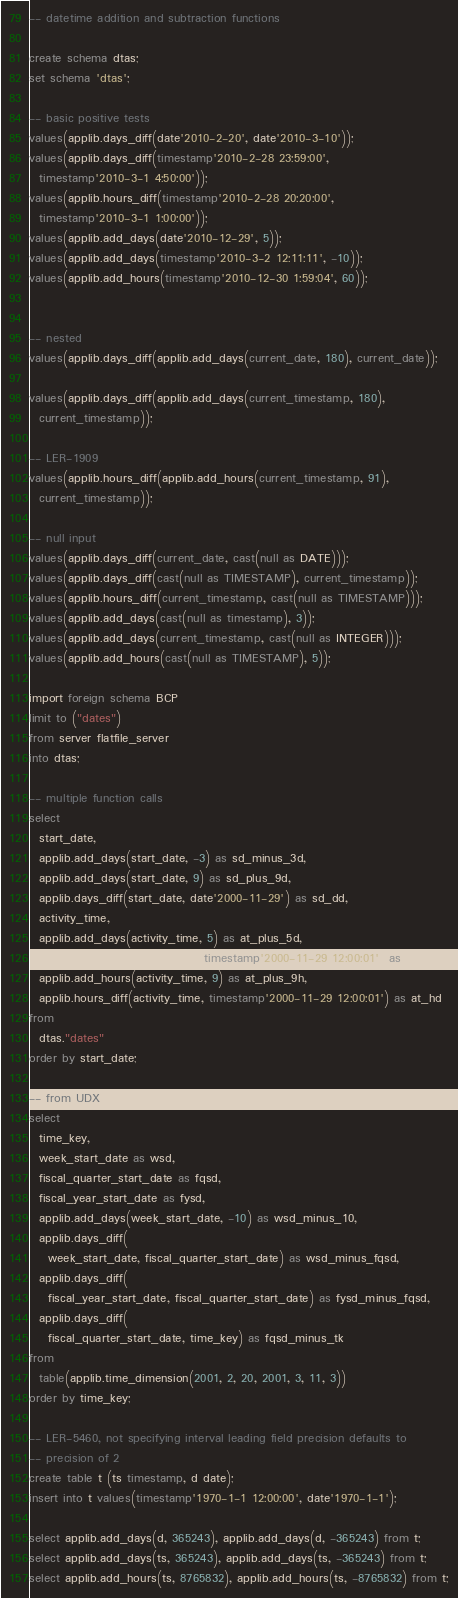Convert code to text. <code><loc_0><loc_0><loc_500><loc_500><_SQL_>-- datetime addition and subtraction functions

create schema dtas;
set schema 'dtas';

-- basic positive tests
values(applib.days_diff(date'2010-2-20', date'2010-3-10'));
values(applib.days_diff(timestamp'2010-2-28 23:59:00',
  timestamp'2010-3-1 4:50:00'));
values(applib.hours_diff(timestamp'2010-2-28 20:20:00',
  timestamp'2010-3-1 1:00:00'));
values(applib.add_days(date'2010-12-29', 5));
values(applib.add_days(timestamp'2010-3-2 12:11:11', -10));
values(applib.add_hours(timestamp'2010-12-30 1:59:04', 60));


-- nested
values(applib.days_diff(applib.add_days(current_date, 180), current_date));

values(applib.days_diff(applib.add_days(current_timestamp, 180), 
  current_timestamp));

-- LER-1909
values(applib.hours_diff(applib.add_hours(current_timestamp, 91),
  current_timestamp));

-- null input
values(applib.days_diff(current_date, cast(null as DATE)));
values(applib.days_diff(cast(null as TIMESTAMP), current_timestamp));
values(applib.hours_diff(current_timestamp, cast(null as TIMESTAMP)));
values(applib.add_days(cast(null as timestamp), 3));
values(applib.add_days(current_timestamp, cast(null as INTEGER)));
values(applib.add_hours(cast(null as TIMESTAMP), 5));

import foreign schema BCP 
limit to ("dates")
from server flatfile_server
into dtas;

-- multiple function calls 
select 
  start_date, 
  applib.add_days(start_date, -3) as sd_minus_3d,
  applib.add_days(start_date, 9) as sd_plus_9d,
  applib.days_diff(start_date, date'2000-11-29') as sd_dd,
  activity_time,
  applib.add_days(activity_time, 5) as at_plus_5d,
  applib.days_diff(activity_time, timestamp'2000-11-29 12:00:01') as at_dd,
  applib.add_hours(activity_time, 9) as at_plus_9h,
  applib.hours_diff(activity_time, timestamp'2000-11-29 12:00:01') as at_hd
from
  dtas."dates"
order by start_date;

-- from UDX
select
  time_key,
  week_start_date as wsd,
  fiscal_quarter_start_date as fqsd,
  fiscal_year_start_date as fysd,
  applib.add_days(week_start_date, -10) as wsd_minus_10,
  applib.days_diff(
    week_start_date, fiscal_quarter_start_date) as wsd_minus_fqsd,
  applib.days_diff(
    fiscal_year_start_date, fiscal_quarter_start_date) as fysd_minus_fqsd,
  applib.days_diff(
    fiscal_quarter_start_date, time_key) as fqsd_minus_tk
from
  table(applib.time_dimension(2001, 2, 20, 2001, 3, 11, 3))
order by time_key;

-- LER-5460, not specifying interval leading field precision defaults to 
-- precision of 2
create table t (ts timestamp, d date);
insert into t values(timestamp'1970-1-1 12:00:00', date'1970-1-1');

select applib.add_days(d, 365243), applib.add_days(d, -365243) from t;
select applib.add_days(ts, 365243), applib.add_days(ts, -365243) from t;
select applib.add_hours(ts, 8765832), applib.add_hours(ts, -8765832) from t;
</code> 